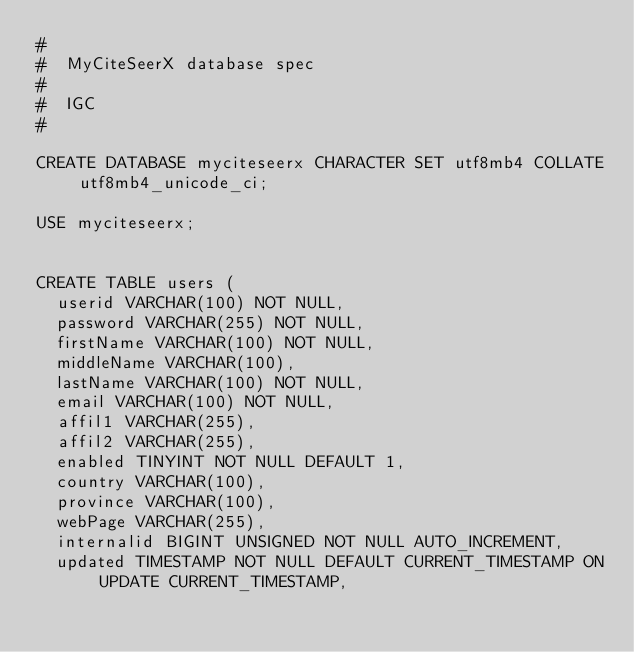<code> <loc_0><loc_0><loc_500><loc_500><_SQL_>#
#  MyCiteSeerX database spec
#
#  IGC
#

CREATE DATABASE myciteseerx CHARACTER SET utf8mb4 COLLATE utf8mb4_unicode_ci;

USE myciteseerx;


CREATE TABLE users (
  userid VARCHAR(100) NOT NULL,
  password VARCHAR(255) NOT NULL,
  firstName VARCHAR(100) NOT NULL,
  middleName VARCHAR(100),
  lastName VARCHAR(100) NOT NULL,
  email VARCHAR(100) NOT NULL,
  affil1 VARCHAR(255),
  affil2 VARCHAR(255),
  enabled TINYINT NOT NULL DEFAULT 1,
  country VARCHAR(100),
  province VARCHAR(100),
  webPage VARCHAR(255),
  internalid BIGINT UNSIGNED NOT NULL AUTO_INCREMENT,
  updated TIMESTAMP NOT NULL DEFAULT CURRENT_TIMESTAMP ON UPDATE CURRENT_TIMESTAMP,</code> 